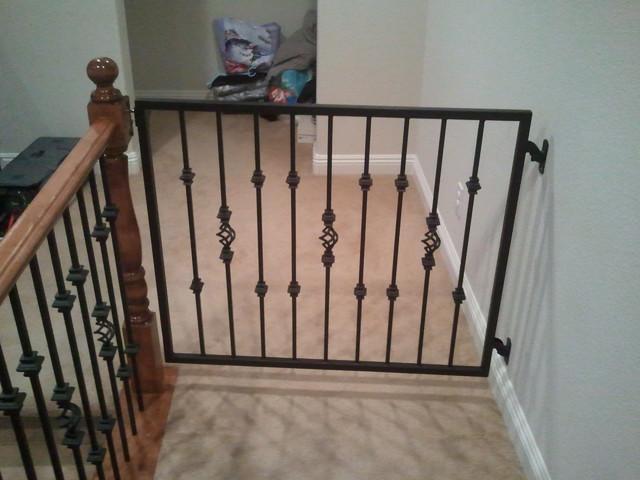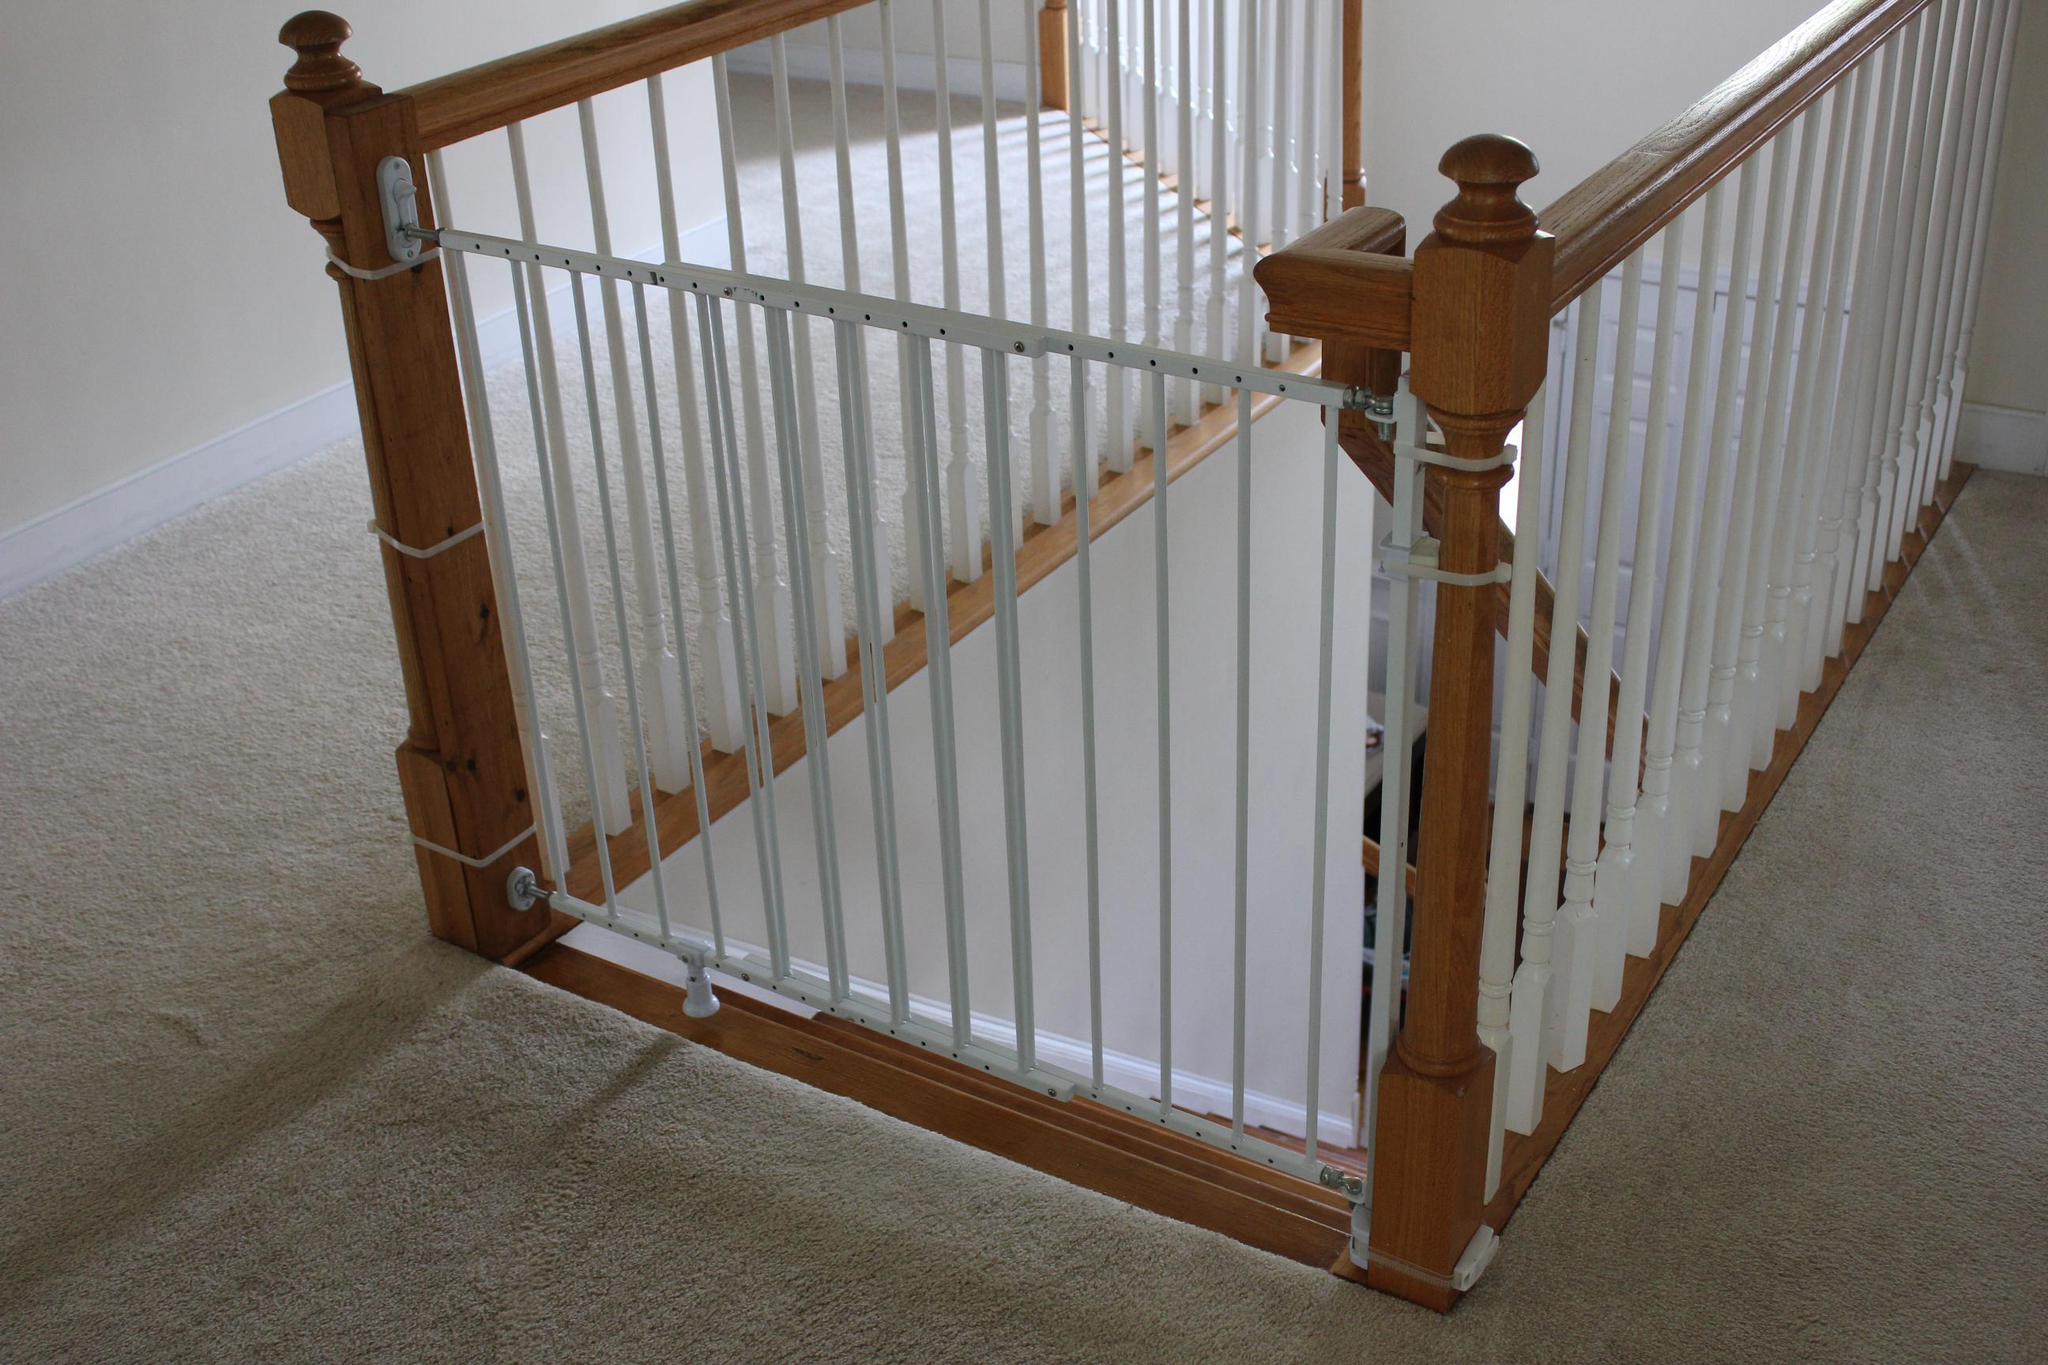The first image is the image on the left, the second image is the image on the right. For the images displayed, is the sentence "Some of the floors upstairs are not carpeted." factually correct? Answer yes or no. No. The first image is the image on the left, the second image is the image on the right. Given the left and right images, does the statement "The stairway posts are all dark wood." hold true? Answer yes or no. Yes. 